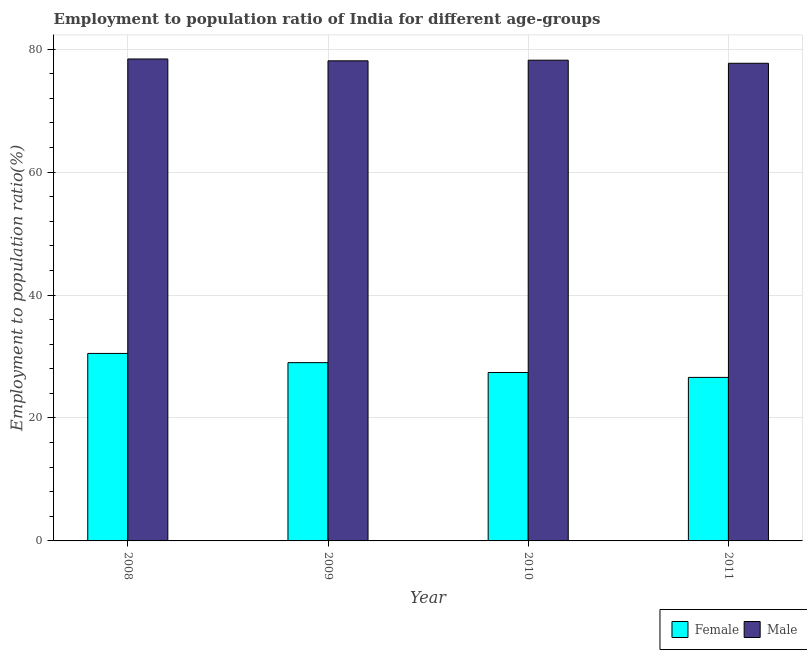How many different coloured bars are there?
Offer a terse response. 2. What is the employment to population ratio(female) in 2011?
Keep it short and to the point. 26.6. Across all years, what is the maximum employment to population ratio(female)?
Offer a terse response. 30.5. Across all years, what is the minimum employment to population ratio(female)?
Make the answer very short. 26.6. In which year was the employment to population ratio(male) maximum?
Make the answer very short. 2008. In which year was the employment to population ratio(male) minimum?
Provide a succinct answer. 2011. What is the total employment to population ratio(male) in the graph?
Offer a very short reply. 312.4. What is the difference between the employment to population ratio(male) in 2009 and that in 2010?
Give a very brief answer. -0.1. What is the difference between the employment to population ratio(male) in 2009 and the employment to population ratio(female) in 2010?
Your answer should be very brief. -0.1. What is the average employment to population ratio(male) per year?
Make the answer very short. 78.1. In the year 2010, what is the difference between the employment to population ratio(female) and employment to population ratio(male)?
Your answer should be very brief. 0. In how many years, is the employment to population ratio(female) greater than 32 %?
Provide a short and direct response. 0. What is the ratio of the employment to population ratio(female) in 2008 to that in 2011?
Ensure brevity in your answer.  1.15. Is the difference between the employment to population ratio(female) in 2009 and 2010 greater than the difference between the employment to population ratio(male) in 2009 and 2010?
Provide a short and direct response. No. What is the difference between the highest and the second highest employment to population ratio(female)?
Your answer should be very brief. 1.5. What is the difference between the highest and the lowest employment to population ratio(female)?
Ensure brevity in your answer.  3.9. Is the sum of the employment to population ratio(female) in 2009 and 2011 greater than the maximum employment to population ratio(male) across all years?
Your answer should be very brief. Yes. How many bars are there?
Provide a short and direct response. 8. Are all the bars in the graph horizontal?
Offer a terse response. No. Are the values on the major ticks of Y-axis written in scientific E-notation?
Provide a short and direct response. No. Does the graph contain any zero values?
Make the answer very short. No. Does the graph contain grids?
Your answer should be compact. Yes. How many legend labels are there?
Ensure brevity in your answer.  2. What is the title of the graph?
Provide a short and direct response. Employment to population ratio of India for different age-groups. Does "From Government" appear as one of the legend labels in the graph?
Your answer should be very brief. No. What is the label or title of the X-axis?
Your response must be concise. Year. What is the label or title of the Y-axis?
Provide a succinct answer. Employment to population ratio(%). What is the Employment to population ratio(%) in Female in 2008?
Provide a short and direct response. 30.5. What is the Employment to population ratio(%) in Male in 2008?
Provide a short and direct response. 78.4. What is the Employment to population ratio(%) of Female in 2009?
Give a very brief answer. 29. What is the Employment to population ratio(%) of Male in 2009?
Provide a short and direct response. 78.1. What is the Employment to population ratio(%) of Female in 2010?
Ensure brevity in your answer.  27.4. What is the Employment to population ratio(%) in Male in 2010?
Make the answer very short. 78.2. What is the Employment to population ratio(%) in Female in 2011?
Your answer should be compact. 26.6. What is the Employment to population ratio(%) in Male in 2011?
Make the answer very short. 77.7. Across all years, what is the maximum Employment to population ratio(%) in Female?
Your response must be concise. 30.5. Across all years, what is the maximum Employment to population ratio(%) in Male?
Your answer should be very brief. 78.4. Across all years, what is the minimum Employment to population ratio(%) of Female?
Provide a succinct answer. 26.6. Across all years, what is the minimum Employment to population ratio(%) in Male?
Your answer should be compact. 77.7. What is the total Employment to population ratio(%) in Female in the graph?
Make the answer very short. 113.5. What is the total Employment to population ratio(%) of Male in the graph?
Provide a succinct answer. 312.4. What is the difference between the Employment to population ratio(%) in Female in 2008 and that in 2009?
Your response must be concise. 1.5. What is the difference between the Employment to population ratio(%) in Male in 2008 and that in 2009?
Give a very brief answer. 0.3. What is the difference between the Employment to population ratio(%) in Male in 2008 and that in 2011?
Offer a terse response. 0.7. What is the difference between the Employment to population ratio(%) of Male in 2009 and that in 2010?
Offer a terse response. -0.1. What is the difference between the Employment to population ratio(%) in Female in 2009 and that in 2011?
Your answer should be compact. 2.4. What is the difference between the Employment to population ratio(%) of Male in 2009 and that in 2011?
Keep it short and to the point. 0.4. What is the difference between the Employment to population ratio(%) in Female in 2008 and the Employment to population ratio(%) in Male in 2009?
Ensure brevity in your answer.  -47.6. What is the difference between the Employment to population ratio(%) in Female in 2008 and the Employment to population ratio(%) in Male in 2010?
Make the answer very short. -47.7. What is the difference between the Employment to population ratio(%) in Female in 2008 and the Employment to population ratio(%) in Male in 2011?
Make the answer very short. -47.2. What is the difference between the Employment to population ratio(%) of Female in 2009 and the Employment to population ratio(%) of Male in 2010?
Provide a short and direct response. -49.2. What is the difference between the Employment to population ratio(%) of Female in 2009 and the Employment to population ratio(%) of Male in 2011?
Provide a short and direct response. -48.7. What is the difference between the Employment to population ratio(%) of Female in 2010 and the Employment to population ratio(%) of Male in 2011?
Offer a very short reply. -50.3. What is the average Employment to population ratio(%) of Female per year?
Offer a very short reply. 28.38. What is the average Employment to population ratio(%) of Male per year?
Ensure brevity in your answer.  78.1. In the year 2008, what is the difference between the Employment to population ratio(%) in Female and Employment to population ratio(%) in Male?
Your response must be concise. -47.9. In the year 2009, what is the difference between the Employment to population ratio(%) of Female and Employment to population ratio(%) of Male?
Offer a terse response. -49.1. In the year 2010, what is the difference between the Employment to population ratio(%) in Female and Employment to population ratio(%) in Male?
Give a very brief answer. -50.8. In the year 2011, what is the difference between the Employment to population ratio(%) of Female and Employment to population ratio(%) of Male?
Your response must be concise. -51.1. What is the ratio of the Employment to population ratio(%) of Female in 2008 to that in 2009?
Give a very brief answer. 1.05. What is the ratio of the Employment to population ratio(%) of Female in 2008 to that in 2010?
Make the answer very short. 1.11. What is the ratio of the Employment to population ratio(%) in Male in 2008 to that in 2010?
Offer a very short reply. 1. What is the ratio of the Employment to population ratio(%) in Female in 2008 to that in 2011?
Your answer should be compact. 1.15. What is the ratio of the Employment to population ratio(%) in Female in 2009 to that in 2010?
Ensure brevity in your answer.  1.06. What is the ratio of the Employment to population ratio(%) in Female in 2009 to that in 2011?
Provide a short and direct response. 1.09. What is the ratio of the Employment to population ratio(%) of Male in 2009 to that in 2011?
Your answer should be very brief. 1.01. What is the ratio of the Employment to population ratio(%) of Female in 2010 to that in 2011?
Offer a terse response. 1.03. What is the ratio of the Employment to population ratio(%) in Male in 2010 to that in 2011?
Offer a very short reply. 1.01. What is the difference between the highest and the second highest Employment to population ratio(%) of Male?
Your response must be concise. 0.2. What is the difference between the highest and the lowest Employment to population ratio(%) of Female?
Offer a terse response. 3.9. What is the difference between the highest and the lowest Employment to population ratio(%) of Male?
Provide a short and direct response. 0.7. 